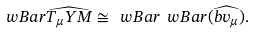<formula> <loc_0><loc_0><loc_500><loc_500>\ w B a r \widehat { T _ { \mu } Y M } \cong \ w B a r \ w B a r ( \widehat { b v _ { \mu } } ) .</formula> 